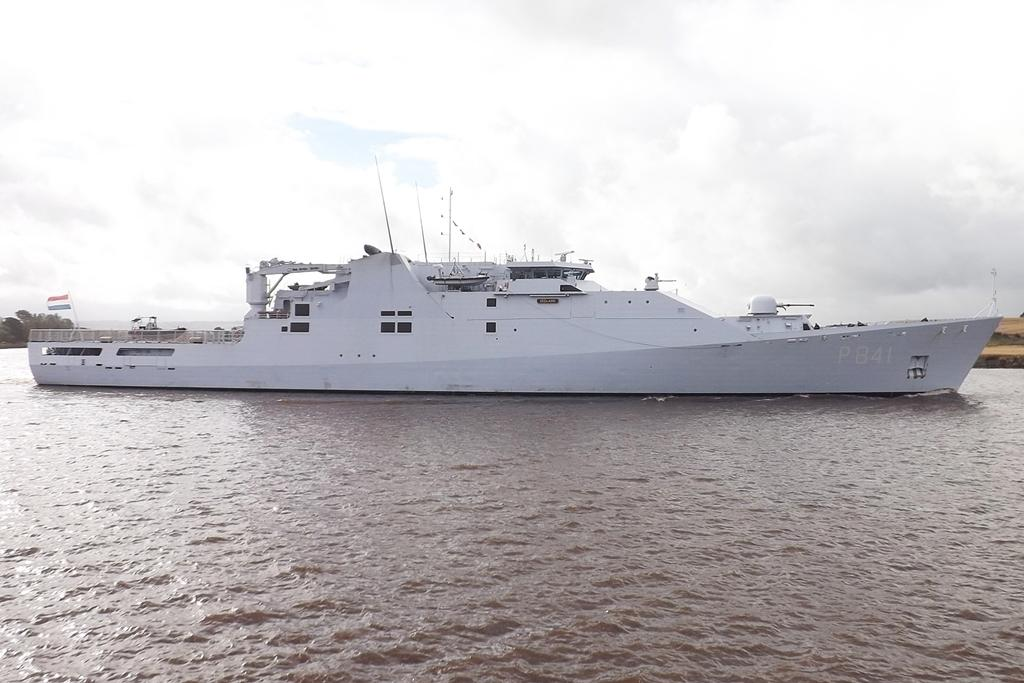What is the main subject in the water in the image? There is a ship in the water in the image. What structure can be seen in the image? There is a flagpole in the image. What type of vegetation is visible in the image? There are trees visible in the image. What is the condition of the sky in the image? The sky is cloudy in the image. What type of stone is being used to build the plantation in the image? There is no plantation present in the image, and therefore no stone being used for construction. What type of work can be seen being performed in the image? There is no work being performed in the image; it features a ship in the water, a flagpole, trees, and a cloudy sky. 